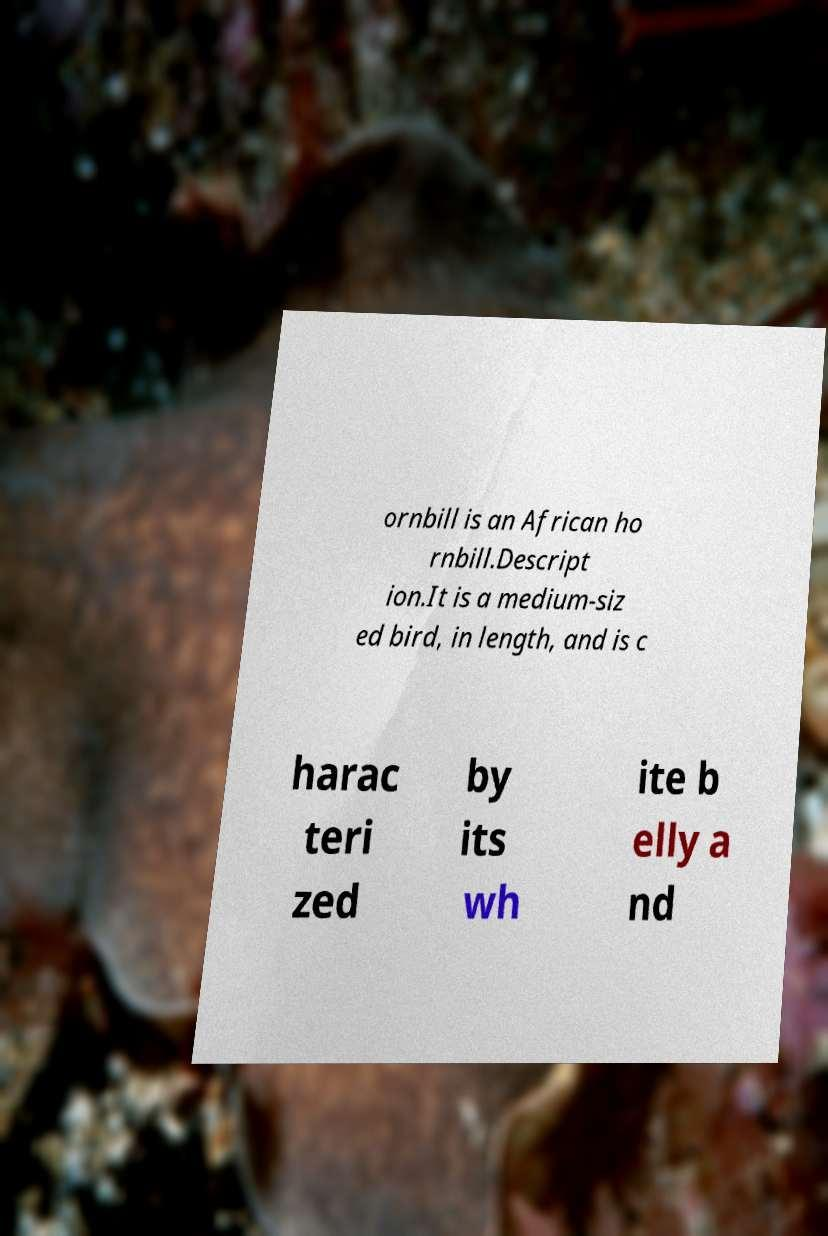What messages or text are displayed in this image? I need them in a readable, typed format. ornbill is an African ho rnbill.Descript ion.It is a medium-siz ed bird, in length, and is c harac teri zed by its wh ite b elly a nd 